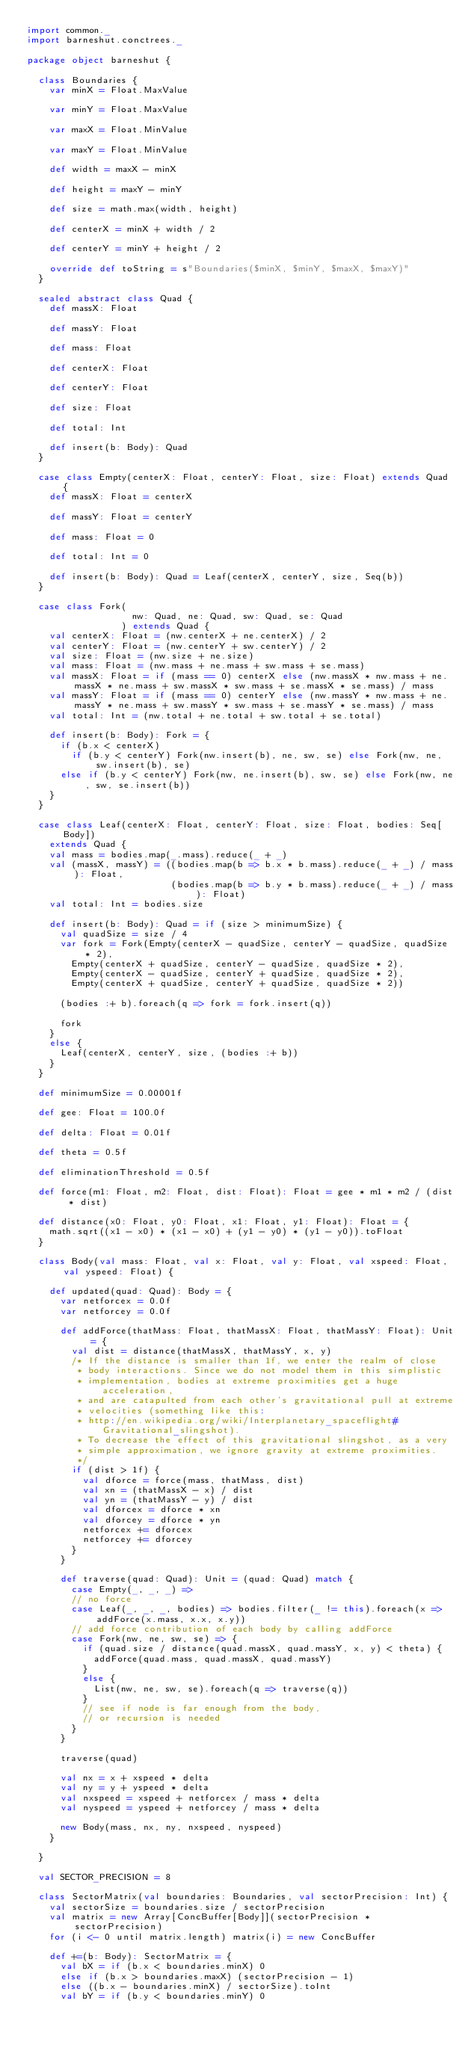<code> <loc_0><loc_0><loc_500><loc_500><_Scala_>import common._
import barneshut.conctrees._

package object barneshut {

  class Boundaries {
    var minX = Float.MaxValue

    var minY = Float.MaxValue

    var maxX = Float.MinValue

    var maxY = Float.MinValue

    def width = maxX - minX

    def height = maxY - minY

    def size = math.max(width, height)

    def centerX = minX + width / 2

    def centerY = minY + height / 2

    override def toString = s"Boundaries($minX, $minY, $maxX, $maxY)"
  }

  sealed abstract class Quad {
    def massX: Float

    def massY: Float

    def mass: Float

    def centerX: Float

    def centerY: Float

    def size: Float

    def total: Int

    def insert(b: Body): Quad
  }

  case class Empty(centerX: Float, centerY: Float, size: Float) extends Quad {
    def massX: Float = centerX

    def massY: Float = centerY

    def mass: Float = 0

    def total: Int = 0

    def insert(b: Body): Quad = Leaf(centerX, centerY, size, Seq(b))
  }

  case class Fork(
                   nw: Quad, ne: Quad, sw: Quad, se: Quad
                 ) extends Quad {
    val centerX: Float = (nw.centerX + ne.centerX) / 2
    val centerY: Float = (nw.centerY + sw.centerY) / 2
    val size: Float = (nw.size + ne.size)
    val mass: Float = (nw.mass + ne.mass + sw.mass + se.mass)
    val massX: Float = if (mass == 0) centerX else (nw.massX * nw.mass + ne.massX * ne.mass + sw.massX * sw.mass + se.massX * se.mass) / mass
    val massY: Float = if (mass == 0) centerY else (nw.massY * nw.mass + ne.massY * ne.mass + sw.massY * sw.mass + se.massY * se.mass) / mass
    val total: Int = (nw.total + ne.total + sw.total + se.total)

    def insert(b: Body): Fork = {
      if (b.x < centerX)
        if (b.y < centerY) Fork(nw.insert(b), ne, sw, se) else Fork(nw, ne, sw.insert(b), se)
      else if (b.y < centerY) Fork(nw, ne.insert(b), sw, se) else Fork(nw, ne, sw, se.insert(b))
    }
  }

  case class Leaf(centerX: Float, centerY: Float, size: Float, bodies: Seq[Body])
    extends Quad {
    val mass = bodies.map(_.mass).reduce(_ + _)
    val (massX, massY) = ((bodies.map(b => b.x * b.mass).reduce(_ + _) / mass): Float,
                          (bodies.map(b => b.y * b.mass).reduce(_ + _) / mass): Float)
    val total: Int = bodies.size

    def insert(b: Body): Quad = if (size > minimumSize) {
      val quadSize = size / 4
      var fork = Fork(Empty(centerX - quadSize, centerY - quadSize, quadSize * 2),
        Empty(centerX + quadSize, centerY - quadSize, quadSize * 2),
        Empty(centerX - quadSize, centerY + quadSize, quadSize * 2),
        Empty(centerX + quadSize, centerY + quadSize, quadSize * 2))

      (bodies :+ b).foreach(q => fork = fork.insert(q))

      fork
    }
    else {
      Leaf(centerX, centerY, size, (bodies :+ b))
    }
  }

  def minimumSize = 0.00001f

  def gee: Float = 100.0f

  def delta: Float = 0.01f

  def theta = 0.5f

  def eliminationThreshold = 0.5f

  def force(m1: Float, m2: Float, dist: Float): Float = gee * m1 * m2 / (dist * dist)

  def distance(x0: Float, y0: Float, x1: Float, y1: Float): Float = {
    math.sqrt((x1 - x0) * (x1 - x0) + (y1 - y0) * (y1 - y0)).toFloat
  }

  class Body(val mass: Float, val x: Float, val y: Float, val xspeed: Float, val yspeed: Float) {

    def updated(quad: Quad): Body = {
      var netforcex = 0.0f
      var netforcey = 0.0f

      def addForce(thatMass: Float, thatMassX: Float, thatMassY: Float): Unit = {
        val dist = distance(thatMassX, thatMassY, x, y)
        /* If the distance is smaller than 1f, we enter the realm of close
         * body interactions. Since we do not model them in this simplistic
         * implementation, bodies at extreme proximities get a huge acceleration,
         * and are catapulted from each other's gravitational pull at extreme
         * velocities (something like this:
         * http://en.wikipedia.org/wiki/Interplanetary_spaceflight#Gravitational_slingshot).
         * To decrease the effect of this gravitational slingshot, as a very
         * simple approximation, we ignore gravity at extreme proximities.
         */
        if (dist > 1f) {
          val dforce = force(mass, thatMass, dist)
          val xn = (thatMassX - x) / dist
          val yn = (thatMassY - y) / dist
          val dforcex = dforce * xn
          val dforcey = dforce * yn
          netforcex += dforcex
          netforcey += dforcey
        }
      }

      def traverse(quad: Quad): Unit = (quad: Quad) match {
        case Empty(_, _, _) =>
        // no force
        case Leaf(_, _, _, bodies) => bodies.filter(_ != this).foreach(x => addForce(x.mass, x.x, x.y))
        // add force contribution of each body by calling addForce
        case Fork(nw, ne, sw, se) => {
          if (quad.size / distance(quad.massX, quad.massY, x, y) < theta) {
            addForce(quad.mass, quad.massX, quad.massY)
          }
          else {
            List(nw, ne, sw, se).foreach(q => traverse(q))
          }
          // see if node is far enough from the body,
          // or recursion is needed
        }
      }

      traverse(quad)

      val nx = x + xspeed * delta
      val ny = y + yspeed * delta
      val nxspeed = xspeed + netforcex / mass * delta
      val nyspeed = yspeed + netforcey / mass * delta

      new Body(mass, nx, ny, nxspeed, nyspeed)
    }

  }

  val SECTOR_PRECISION = 8

  class SectorMatrix(val boundaries: Boundaries, val sectorPrecision: Int) {
    val sectorSize = boundaries.size / sectorPrecision
    val matrix = new Array[ConcBuffer[Body]](sectorPrecision * sectorPrecision)
    for (i <- 0 until matrix.length) matrix(i) = new ConcBuffer

    def +=(b: Body): SectorMatrix = {
      val bX = if (b.x < boundaries.minX) 0
      else if (b.x > boundaries.maxX) (sectorPrecision - 1)
      else ((b.x - boundaries.minX) / sectorSize).toInt
      val bY = if (b.y < boundaries.minY) 0</code> 